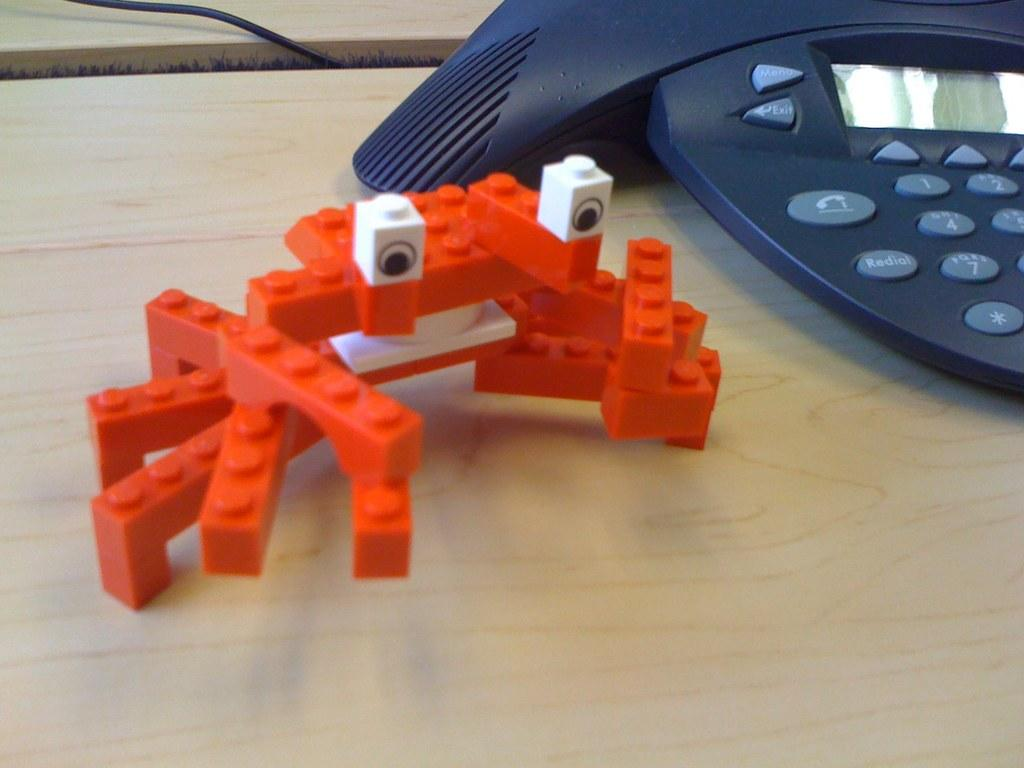<image>
Offer a succinct explanation of the picture presented. An orange lego crab on a wooden table next to a conference phone with the buttons exit and menu. 